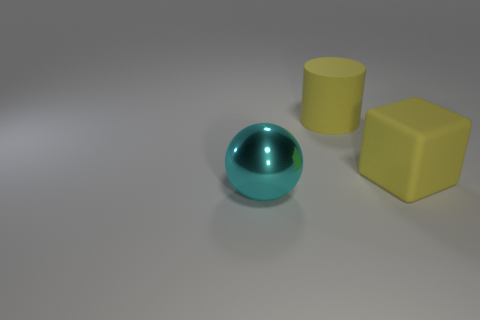Are there any other things that are made of the same material as the big cyan sphere?
Offer a very short reply. No. Are any gray metallic balls visible?
Provide a short and direct response. No. What number of other things are there of the same size as the yellow cylinder?
Give a very brief answer. 2. Is the color of the large object right of the big yellow cylinder the same as the large object that is behind the big rubber block?
Offer a terse response. Yes. Is the material of the large thing behind the rubber block the same as the thing that is on the left side of the large yellow matte cylinder?
Your answer should be very brief. No. What number of metal objects are yellow cubes or big blue cylinders?
Make the answer very short. 0. What is the large object to the right of the yellow object behind the rubber thing in front of the yellow rubber cylinder made of?
Give a very brief answer. Rubber. What color is the large object on the right side of the big object that is behind the large yellow block?
Offer a very short reply. Yellow. How many blocks are either metal things or rubber things?
Your answer should be compact. 1. There is a object that is behind the big yellow rubber object in front of the big rubber cylinder; how many yellow blocks are behind it?
Your answer should be very brief. 0. 